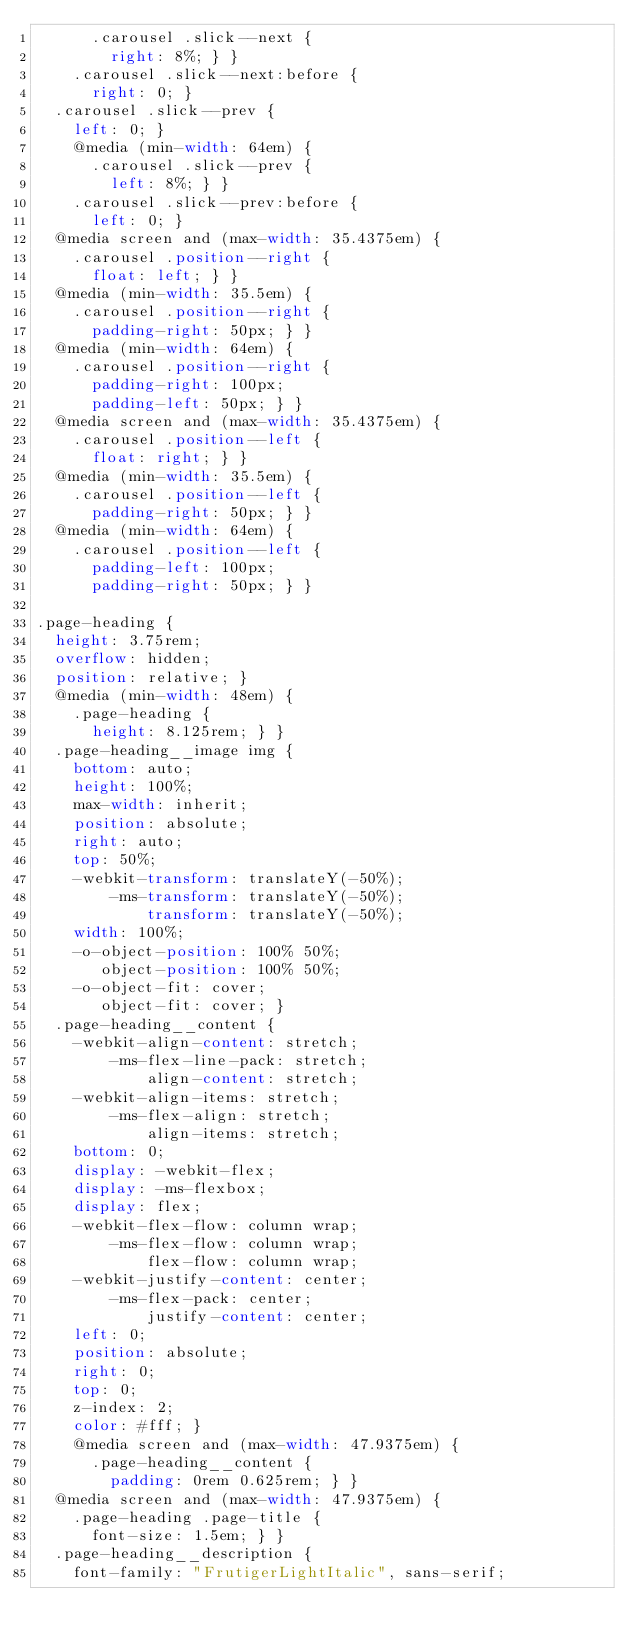Convert code to text. <code><loc_0><loc_0><loc_500><loc_500><_CSS_>      .carousel .slick--next {
        right: 8%; } }
    .carousel .slick--next:before {
      right: 0; }
  .carousel .slick--prev {
    left: 0; }
    @media (min-width: 64em) {
      .carousel .slick--prev {
        left: 8%; } }
    .carousel .slick--prev:before {
      left: 0; }
  @media screen and (max-width: 35.4375em) {
    .carousel .position--right {
      float: left; } }
  @media (min-width: 35.5em) {
    .carousel .position--right {
      padding-right: 50px; } }
  @media (min-width: 64em) {
    .carousel .position--right {
      padding-right: 100px;
      padding-left: 50px; } }
  @media screen and (max-width: 35.4375em) {
    .carousel .position--left {
      float: right; } }
  @media (min-width: 35.5em) {
    .carousel .position--left {
      padding-right: 50px; } }
  @media (min-width: 64em) {
    .carousel .position--left {
      padding-left: 100px;
      padding-right: 50px; } }

.page-heading {
  height: 3.75rem;
  overflow: hidden;
  position: relative; }
  @media (min-width: 48em) {
    .page-heading {
      height: 8.125rem; } }
  .page-heading__image img {
    bottom: auto;
    height: 100%;
    max-width: inherit;
    position: absolute;
    right: auto;
    top: 50%;
    -webkit-transform: translateY(-50%);
        -ms-transform: translateY(-50%);
            transform: translateY(-50%);
    width: 100%;
    -o-object-position: 100% 50%;
       object-position: 100% 50%;
    -o-object-fit: cover;
       object-fit: cover; }
  .page-heading__content {
    -webkit-align-content: stretch;
        -ms-flex-line-pack: stretch;
            align-content: stretch;
    -webkit-align-items: stretch;
        -ms-flex-align: stretch;
            align-items: stretch;
    bottom: 0;
    display: -webkit-flex;
    display: -ms-flexbox;
    display: flex;
    -webkit-flex-flow: column wrap;
        -ms-flex-flow: column wrap;
            flex-flow: column wrap;
    -webkit-justify-content: center;
        -ms-flex-pack: center;
            justify-content: center;
    left: 0;
    position: absolute;
    right: 0;
    top: 0;
    z-index: 2;
    color: #fff; }
    @media screen and (max-width: 47.9375em) {
      .page-heading__content {
        padding: 0rem 0.625rem; } }
  @media screen and (max-width: 47.9375em) {
    .page-heading .page-title {
      font-size: 1.5em; } }
  .page-heading__description {
    font-family: "FrutigerLightItalic", sans-serif;</code> 